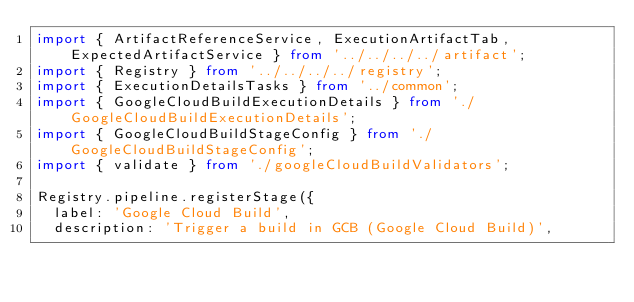<code> <loc_0><loc_0><loc_500><loc_500><_TypeScript_>import { ArtifactReferenceService, ExecutionArtifactTab, ExpectedArtifactService } from '../../../../artifact';
import { Registry } from '../../../../registry';
import { ExecutionDetailsTasks } from '../common';
import { GoogleCloudBuildExecutionDetails } from './GoogleCloudBuildExecutionDetails';
import { GoogleCloudBuildStageConfig } from './GoogleCloudBuildStageConfig';
import { validate } from './googleCloudBuildValidators';

Registry.pipeline.registerStage({
  label: 'Google Cloud Build',
  description: 'Trigger a build in GCB (Google Cloud Build)',</code> 